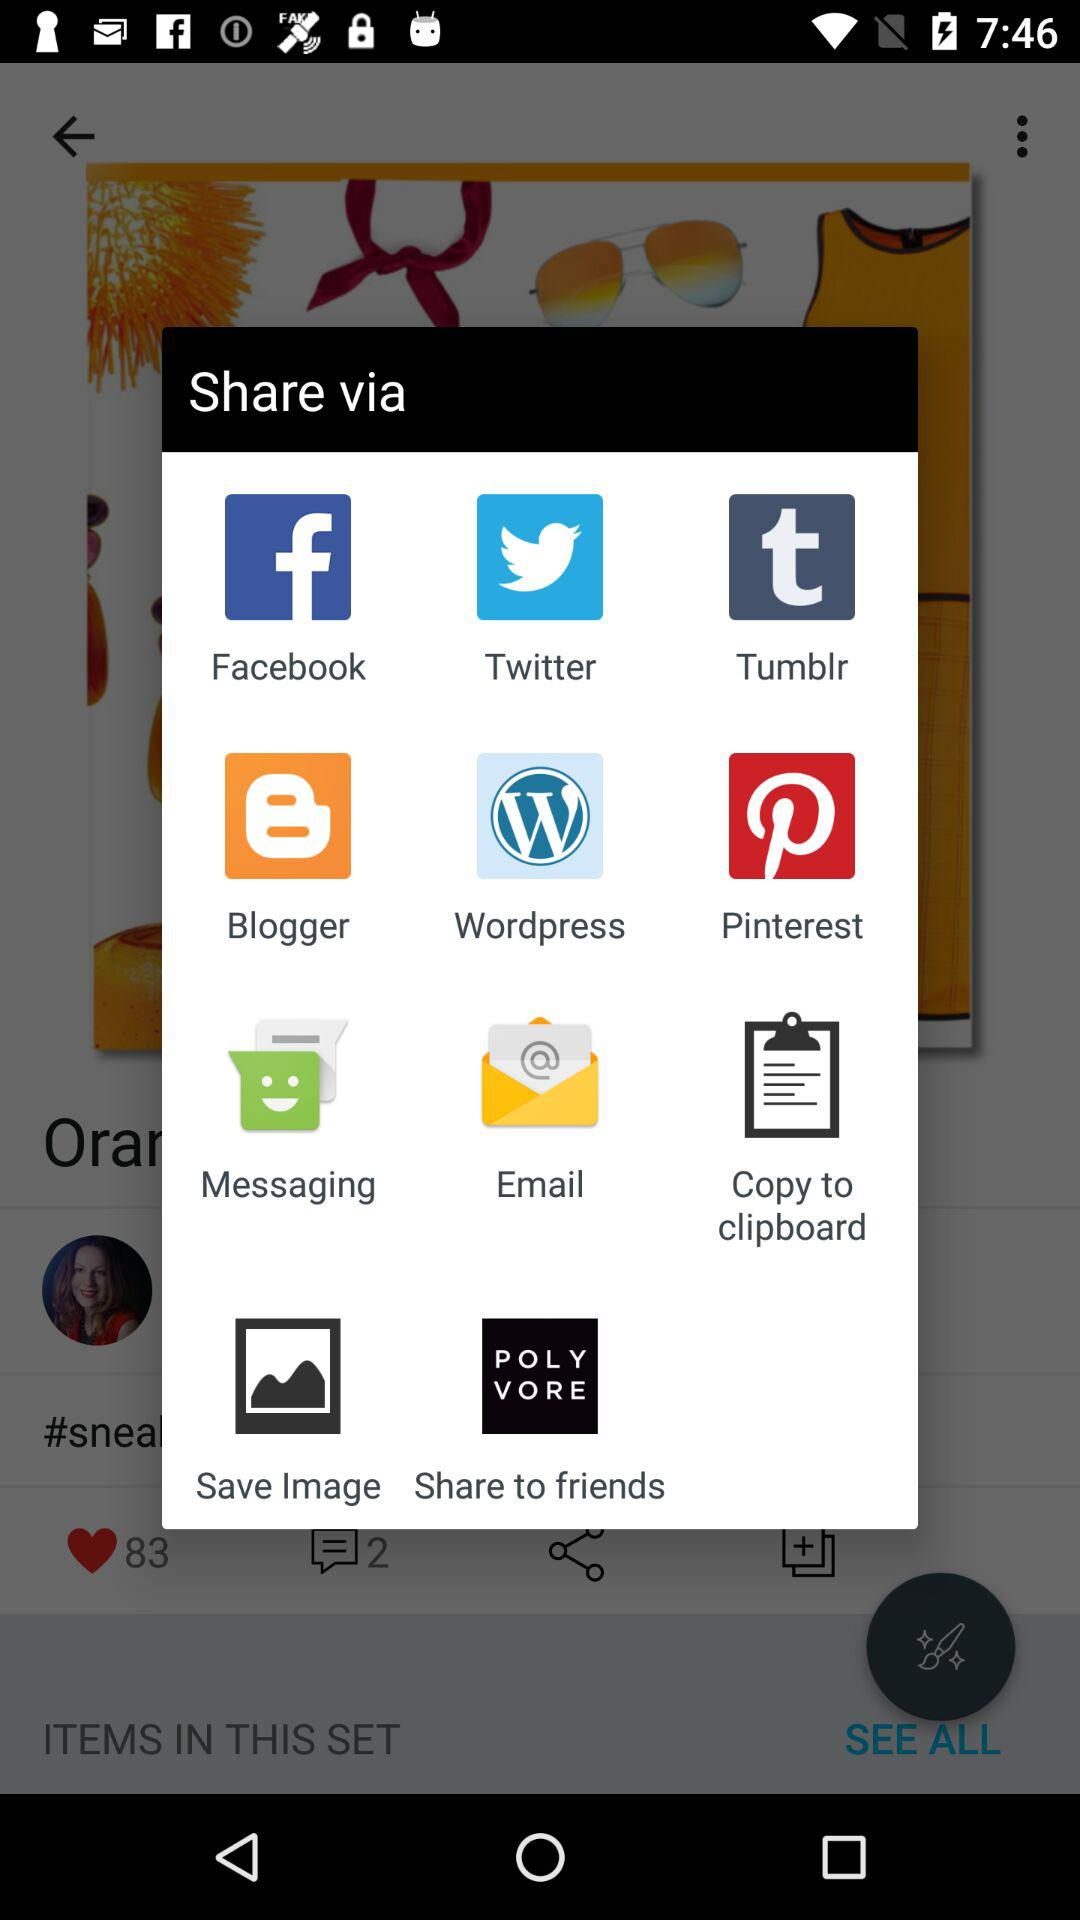What is the number of likes? The number of likes is 83. 